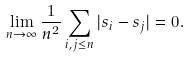<formula> <loc_0><loc_0><loc_500><loc_500>\lim _ { n \to \infty } \frac { 1 } { n ^ { 2 } } \sum _ { i , j \leq n } | s _ { i } - s _ { j } | = 0 .</formula> 